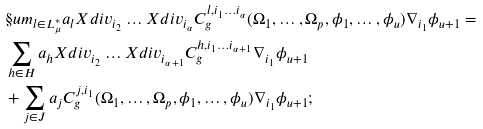Convert formula to latex. <formula><loc_0><loc_0><loc_500><loc_500>& \S u m _ { l \in L ^ { * } _ { \mu } } a _ { l } X d i v _ { i _ { 2 } } \dots X d i v _ { i _ { \alpha } } C ^ { l , i _ { 1 } \dots i _ { \alpha } } _ { g } ( \Omega _ { 1 } , \dots , \Omega _ { p } , \phi _ { 1 } , \dots , \phi _ { u } ) \nabla _ { i _ { 1 } } \phi _ { u + 1 } = \\ & \sum _ { h \in H } a _ { h } X d i v _ { i _ { 2 } } \dots X d i v _ { i _ { \alpha + 1 } } C ^ { h , i _ { 1 } \dots i _ { \alpha + 1 } } _ { g } \nabla _ { i _ { 1 } } \phi _ { u + 1 } \\ & + \sum _ { j \in J } a _ { j } C ^ { j , i _ { 1 } } _ { g } ( \Omega _ { 1 } , \dots , \Omega _ { p } , \phi _ { 1 } , \dots , \phi _ { u } ) \nabla _ { i _ { 1 } } \phi _ { u + 1 } ;</formula> 